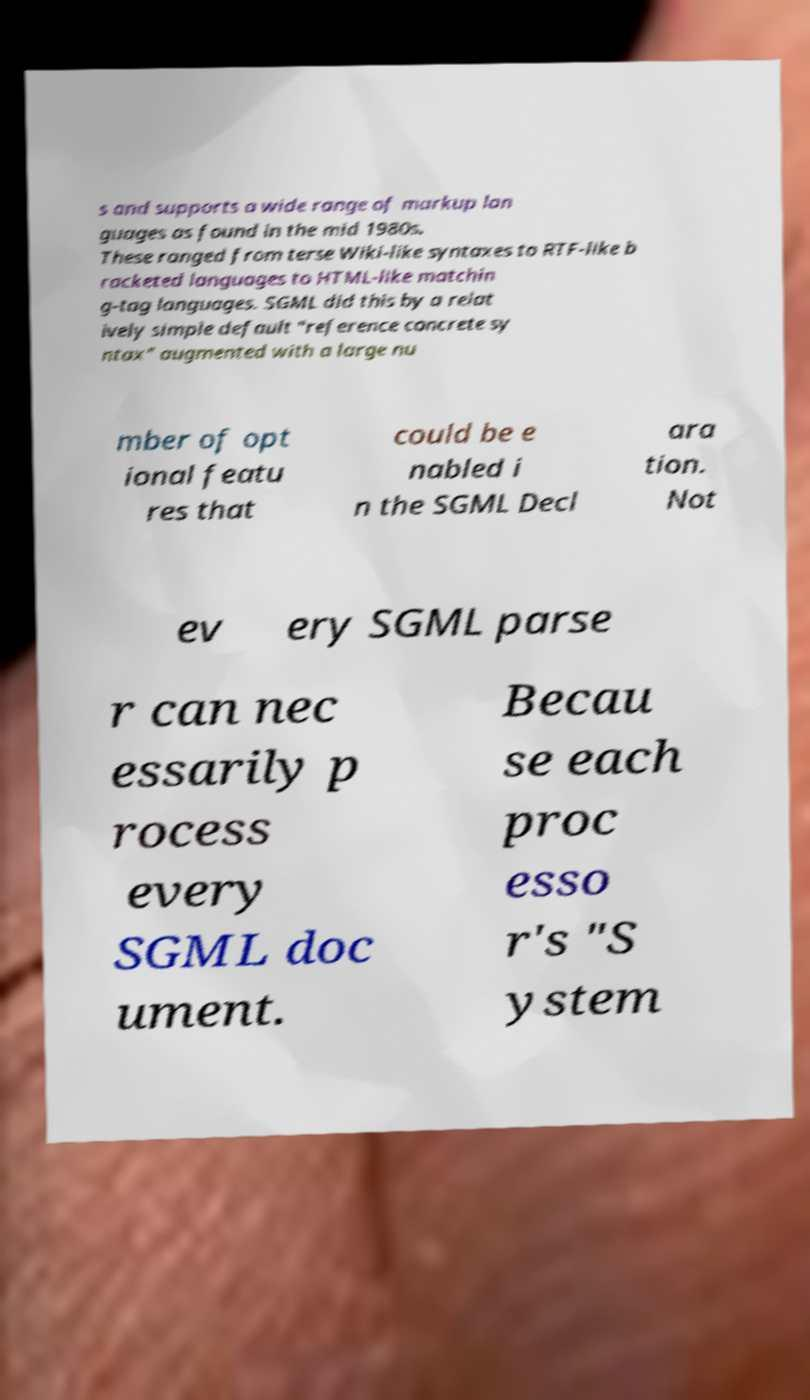Please identify and transcribe the text found in this image. s and supports a wide range of markup lan guages as found in the mid 1980s. These ranged from terse Wiki-like syntaxes to RTF-like b racketed languages to HTML-like matchin g-tag languages. SGML did this by a relat ively simple default "reference concrete sy ntax" augmented with a large nu mber of opt ional featu res that could be e nabled i n the SGML Decl ara tion. Not ev ery SGML parse r can nec essarily p rocess every SGML doc ument. Becau se each proc esso r's "S ystem 